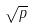Convert formula to latex. <formula><loc_0><loc_0><loc_500><loc_500>\sqrt { p }</formula> 